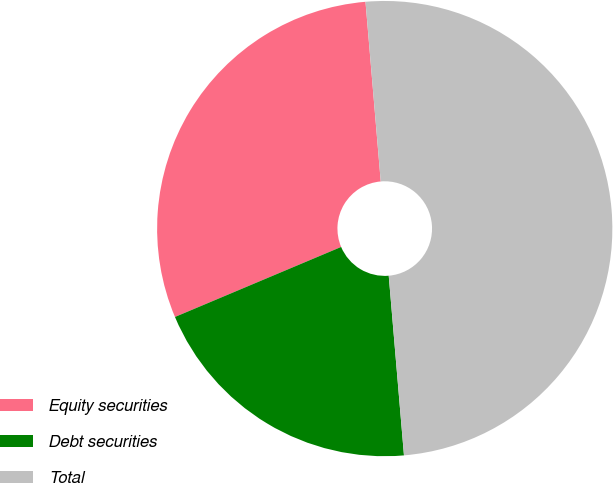<chart> <loc_0><loc_0><loc_500><loc_500><pie_chart><fcel>Equity securities<fcel>Debt securities<fcel>Total<nl><fcel>30.0%<fcel>20.0%<fcel>50.0%<nl></chart> 